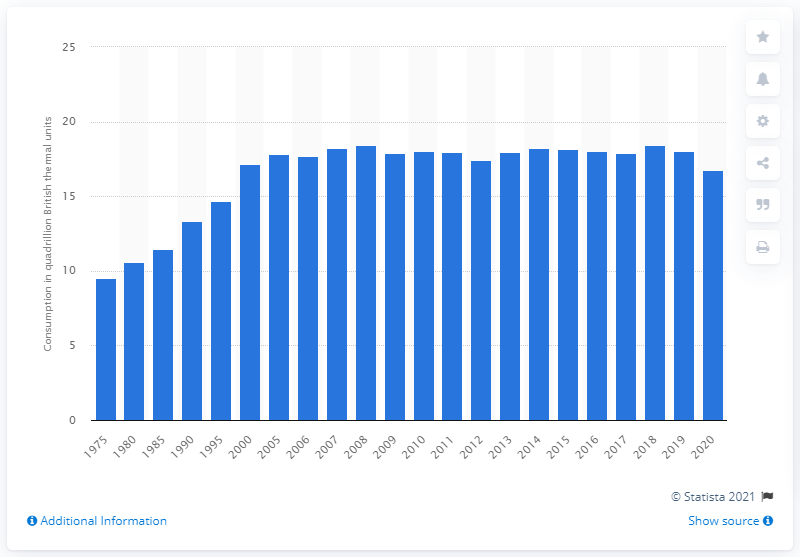Mention a couple of crucial points in this snapshot. The impact of the coronavirus pandemic on energy consumption was significant, with the global demand for energy decreasing by approximately 7.7 quadrillion British thermal units. Energy consumption in the U.S. commercial sector declined in 2020. 